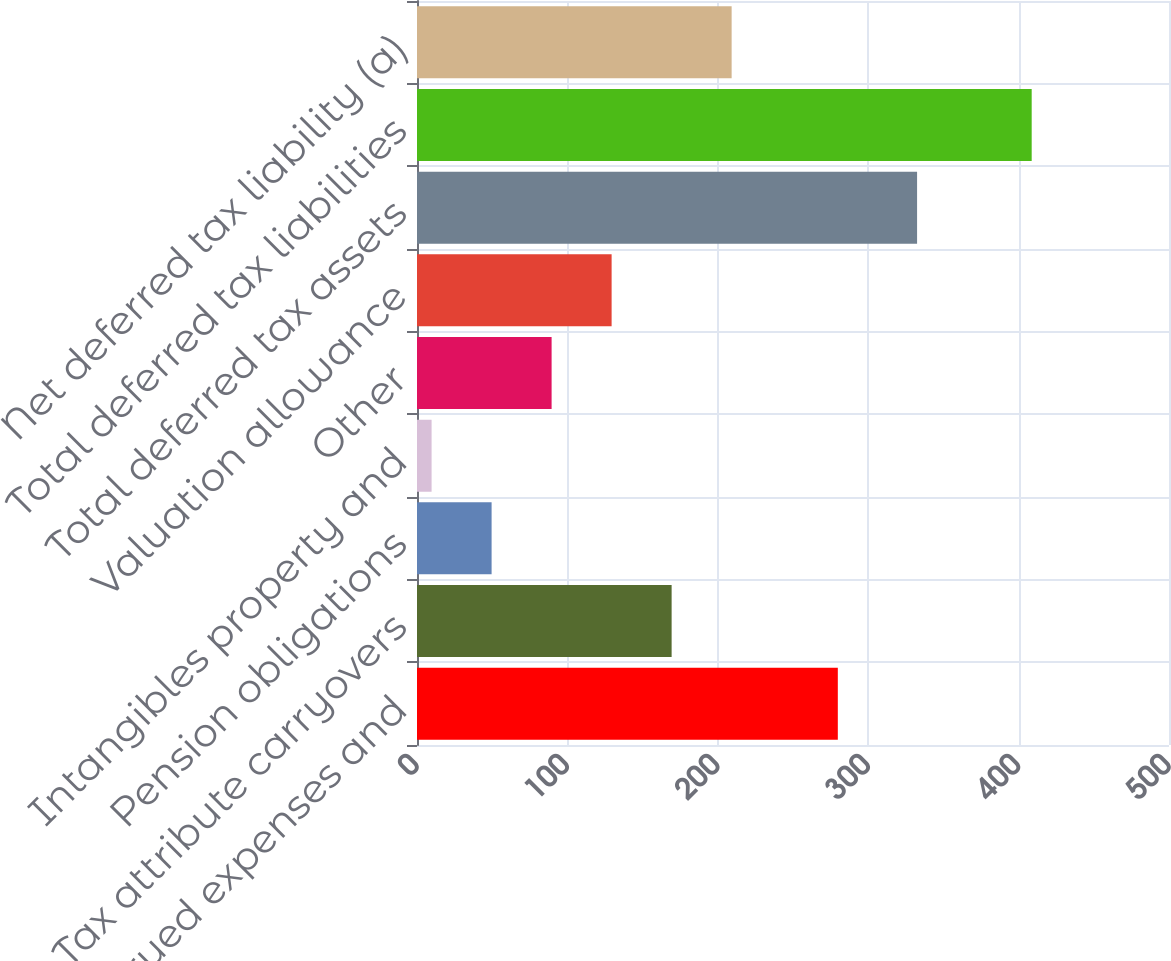Convert chart. <chart><loc_0><loc_0><loc_500><loc_500><bar_chart><fcel>Reserves accrued expenses and<fcel>Tax attribute carryovers<fcel>Pension obligations<fcel>Intangibles property and<fcel>Other<fcel>Valuation allowance<fcel>Total deferred tax assets<fcel>Total deferred tax liabilities<fcel>Net deferred tax liability (a)<nl><fcel>279.8<fcel>169.3<fcel>49.6<fcel>9.7<fcel>89.5<fcel>129.4<fcel>332.5<fcel>408.7<fcel>209.2<nl></chart> 